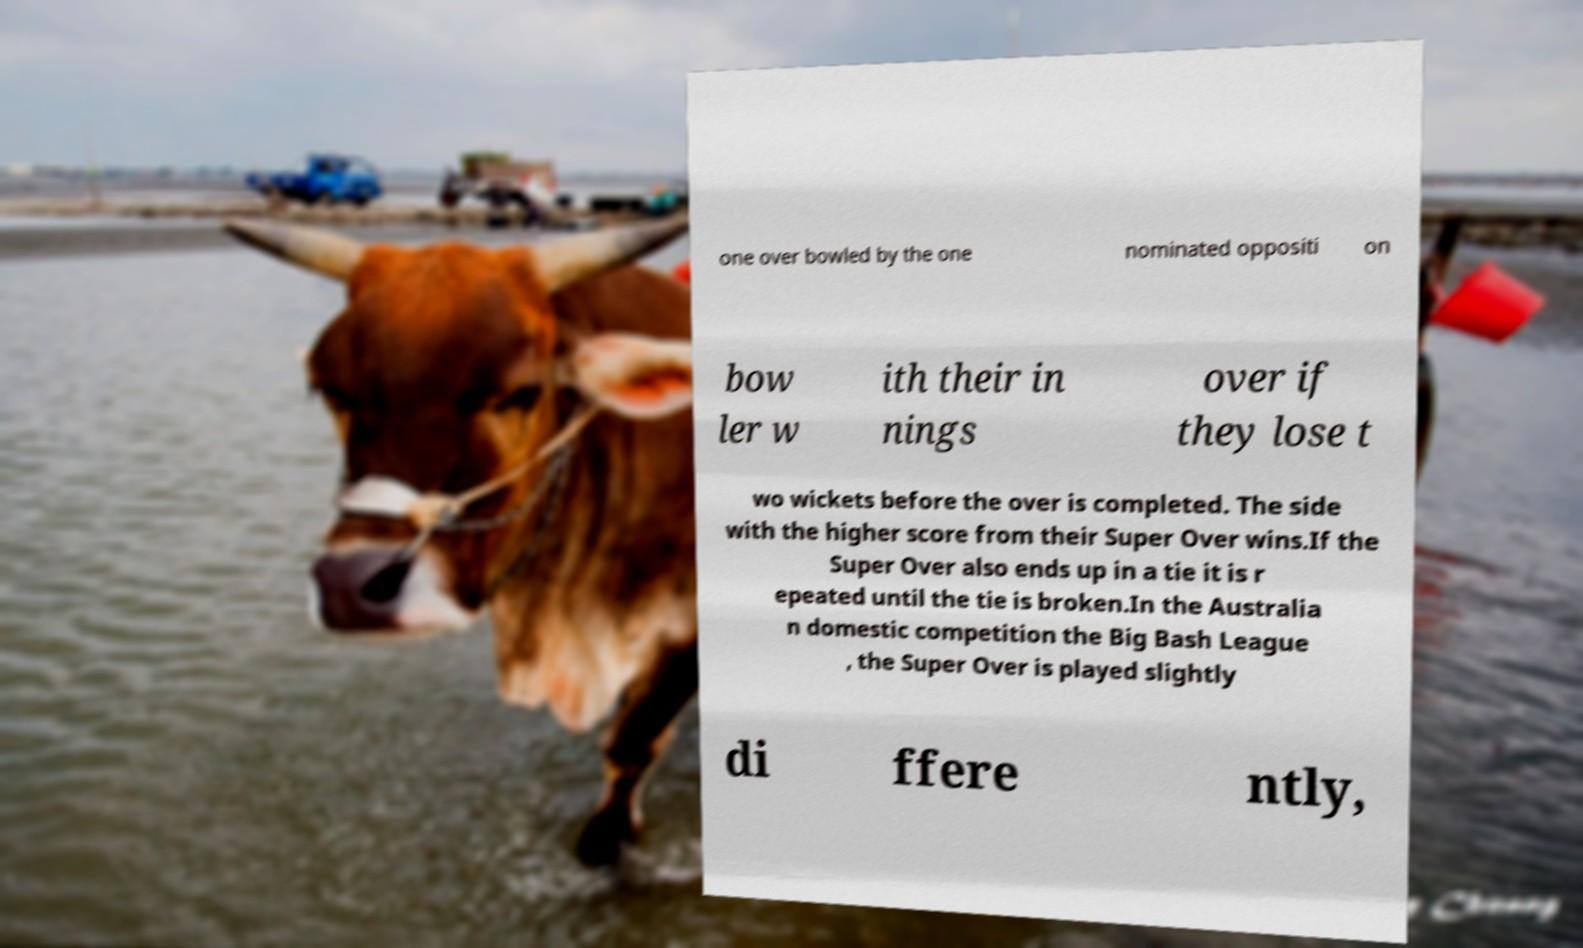Could you extract and type out the text from this image? one over bowled by the one nominated oppositi on bow ler w ith their in nings over if they lose t wo wickets before the over is completed. The side with the higher score from their Super Over wins.If the Super Over also ends up in a tie it is r epeated until the tie is broken.In the Australia n domestic competition the Big Bash League , the Super Over is played slightly di ffere ntly, 